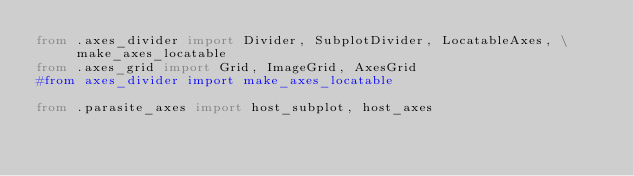Convert code to text. <code><loc_0><loc_0><loc_500><loc_500><_Python_>from .axes_divider import Divider, SubplotDivider, LocatableAxes, \
     make_axes_locatable
from .axes_grid import Grid, ImageGrid, AxesGrid
#from axes_divider import make_axes_locatable

from .parasite_axes import host_subplot, host_axes
</code> 